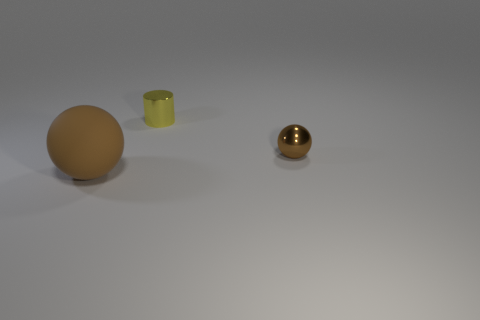Subtract all brown spheres. How many were subtracted if there are1brown spheres left? 1 Add 2 large cyan spheres. How many objects exist? 5 Subtract all balls. How many objects are left? 1 Subtract 0 gray blocks. How many objects are left? 3 Subtract all large brown spheres. Subtract all metallic things. How many objects are left? 0 Add 1 metal things. How many metal things are left? 3 Add 2 yellow metal things. How many yellow metal things exist? 3 